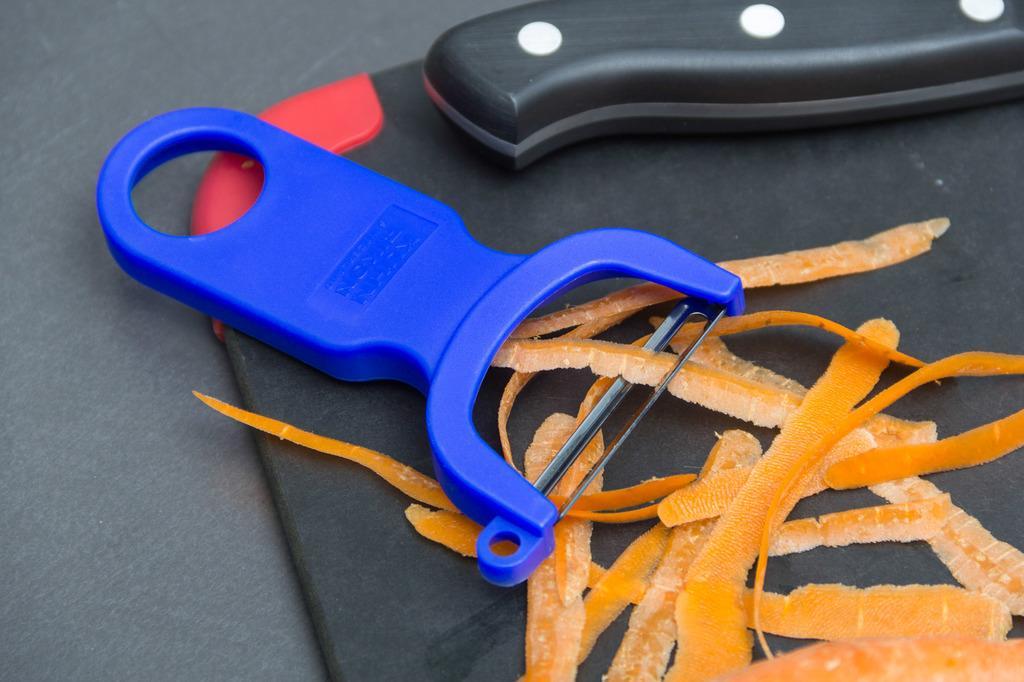Please provide a concise description of this image. In this picture there are carrot pieces, knife and a slicer on a black surface might be a table. 